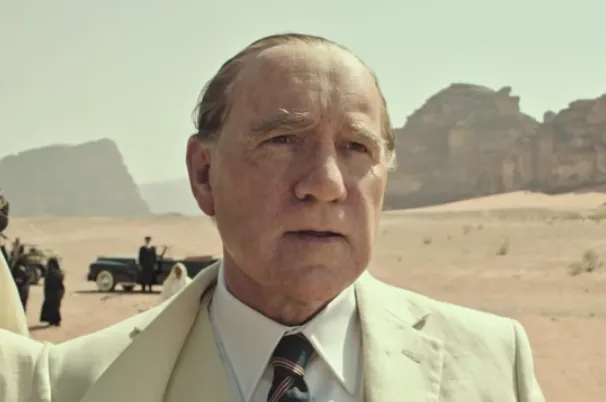How does the character's attire contribute to the interpretation of his role? The character's attire, consisting of a pristine white suit and a carefully chosen tie, visually embodies wealth and meticulous attention to appearance, significant traits of the historical figure J. Paul Getty. The choice to wear such clothing in a desert also reinforces his status and perhaps a disconnection or disregard for the harshness of the environment, underscoring his detachment from everyday struggles. 